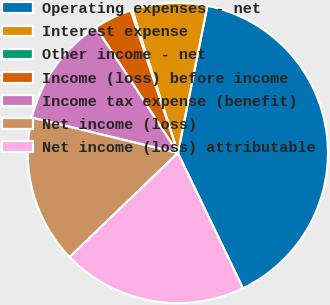Convert chart. <chart><loc_0><loc_0><loc_500><loc_500><pie_chart><fcel>Operating expenses - net<fcel>Interest expense<fcel>Other income - net<fcel>Income (loss) before income<fcel>Income tax expense (benefit)<fcel>Net income (loss)<fcel>Net income (loss) attributable<nl><fcel>39.72%<fcel>8.07%<fcel>0.16%<fcel>4.11%<fcel>12.03%<fcel>15.98%<fcel>19.94%<nl></chart> 